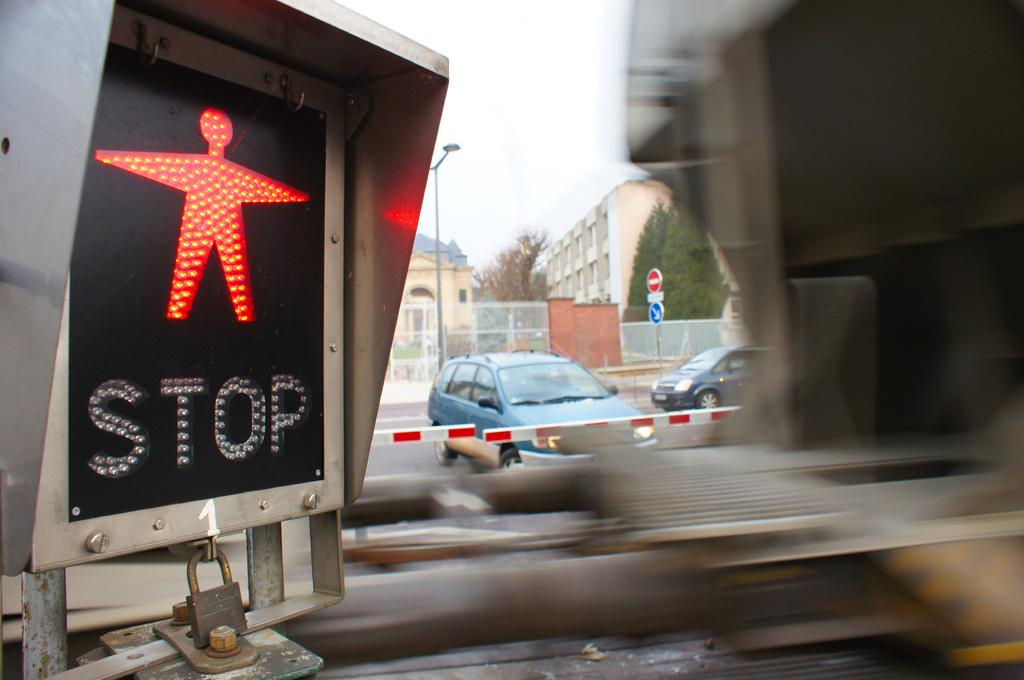Provide a one-sentence caption for the provided image. Stop sign for a person walking on the highway. 